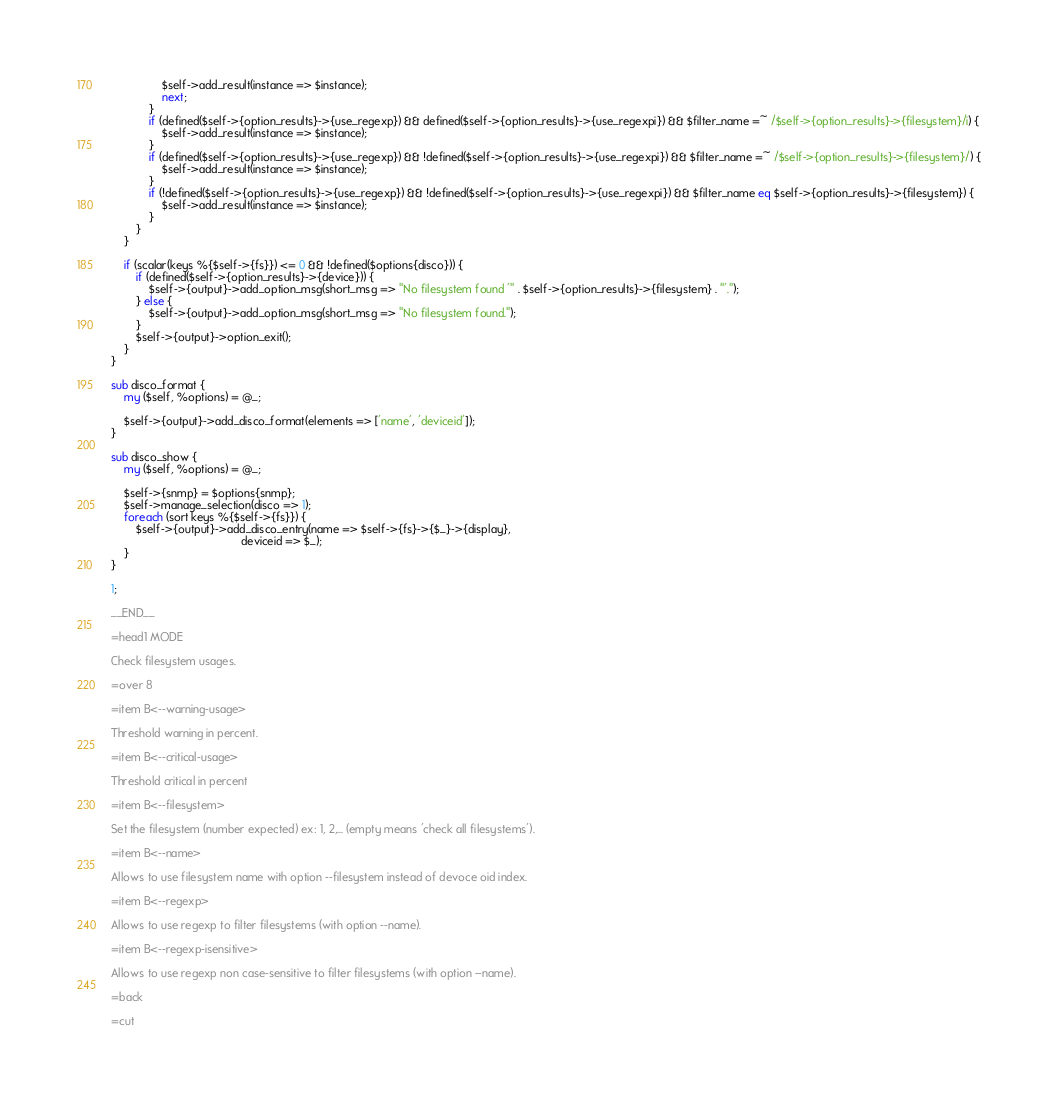Convert code to text. <code><loc_0><loc_0><loc_500><loc_500><_Perl_>                $self->add_result(instance => $instance);
                next;
            }
            if (defined($self->{option_results}->{use_regexp}) && defined($self->{option_results}->{use_regexpi}) && $filter_name =~ /$self->{option_results}->{filesystem}/i) {
                $self->add_result(instance => $instance);
            }
            if (defined($self->{option_results}->{use_regexp}) && !defined($self->{option_results}->{use_regexpi}) && $filter_name =~ /$self->{option_results}->{filesystem}/) {
                $self->add_result(instance => $instance);
            }
            if (!defined($self->{option_results}->{use_regexp}) && !defined($self->{option_results}->{use_regexpi}) && $filter_name eq $self->{option_results}->{filesystem}) {
                $self->add_result(instance => $instance);
            }
        }    
    }
    
    if (scalar(keys %{$self->{fs}}) <= 0 && !defined($options{disco})) {
        if (defined($self->{option_results}->{device})) {
            $self->{output}->add_option_msg(short_msg => "No filesystem found '" . $self->{option_results}->{filesystem} . "'.");
        } else {
            $self->{output}->add_option_msg(short_msg => "No filesystem found.");
        }
        $self->{output}->option_exit();
    }    
}

sub disco_format {
    my ($self, %options) = @_;
    
    $self->{output}->add_disco_format(elements => ['name', 'deviceid']);
}

sub disco_show {
    my ($self, %options) = @_;

    $self->{snmp} = $options{snmp};
    $self->manage_selection(disco => 1);
    foreach (sort keys %{$self->{fs}}) {
        $self->{output}->add_disco_entry(name => $self->{fs}->{$_}->{display},
                                         deviceid => $_);
    }
}

1;

__END__

=head1 MODE

Check filesystem usages. 

=over 8

=item B<--warning-usage>

Threshold warning in percent.

=item B<--critical-usage>

Threshold critical in percent

=item B<--filesystem>

Set the filesystem (number expected) ex: 1, 2,... (empty means 'check all filesystems').

=item B<--name>

Allows to use filesystem name with option --filesystem instead of devoce oid index.

=item B<--regexp>

Allows to use regexp to filter filesystems (with option --name).

=item B<--regexp-isensitive>

Allows to use regexp non case-sensitive to filter filesystems (with option --name).

=back

=cut
</code> 